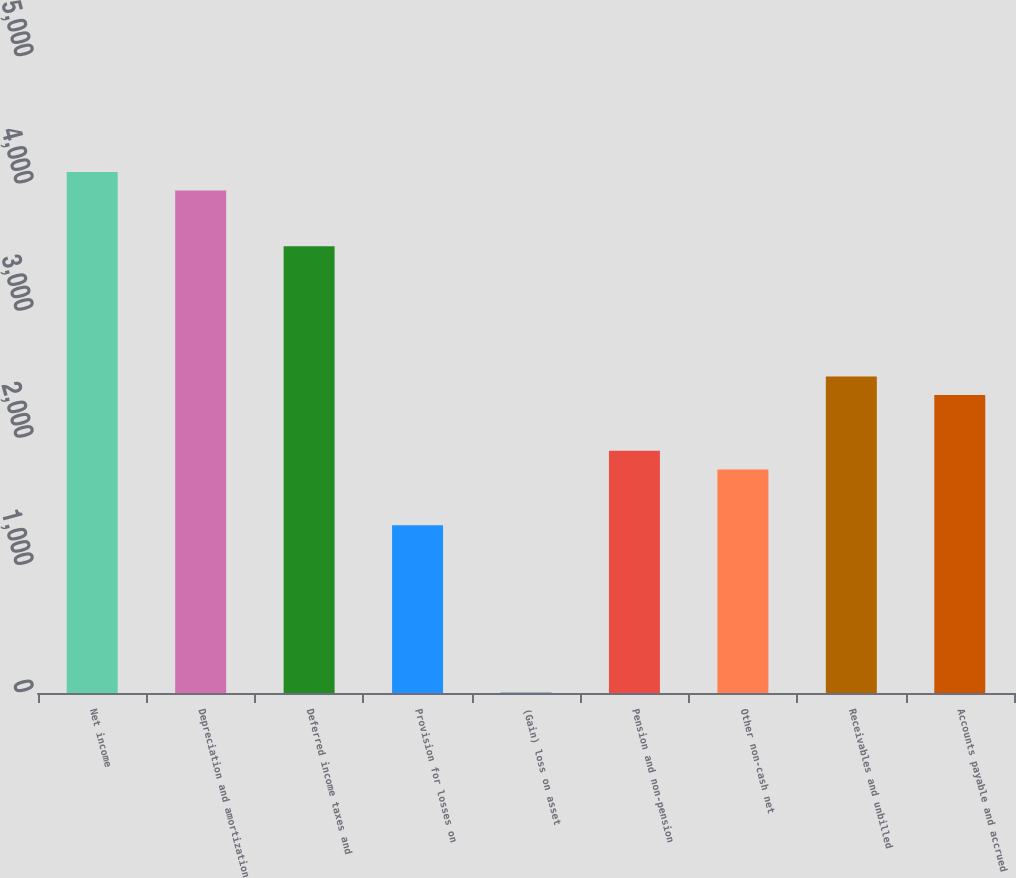<chart> <loc_0><loc_0><loc_500><loc_500><bar_chart><fcel>Net income<fcel>Depreciation and amortization<fcel>Deferred income taxes and<fcel>Provision for losses on<fcel>(Gain) loss on asset<fcel>Pension and non-pension<fcel>Other non-cash net<fcel>Receivables and unbilled<fcel>Accounts payable and accrued<nl><fcel>4096.6<fcel>3950.4<fcel>3511.8<fcel>1318.8<fcel>3<fcel>1903.6<fcel>1757.4<fcel>2488.4<fcel>2342.2<nl></chart> 